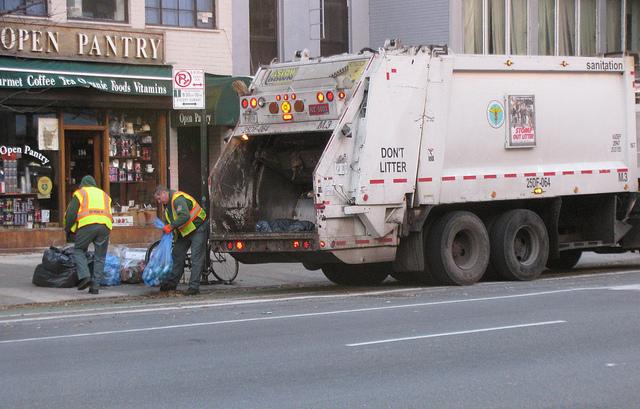What do the words on the dump truck say?
Answer briefly. Don't litter. Is there a fire nearby?
Keep it brief. No. What are people doing?
Concise answer only. Picking up trash. What color is the trash bag the man is holding?
Concise answer only. Blue. What is being thrown away?
Be succinct. Garbage. 